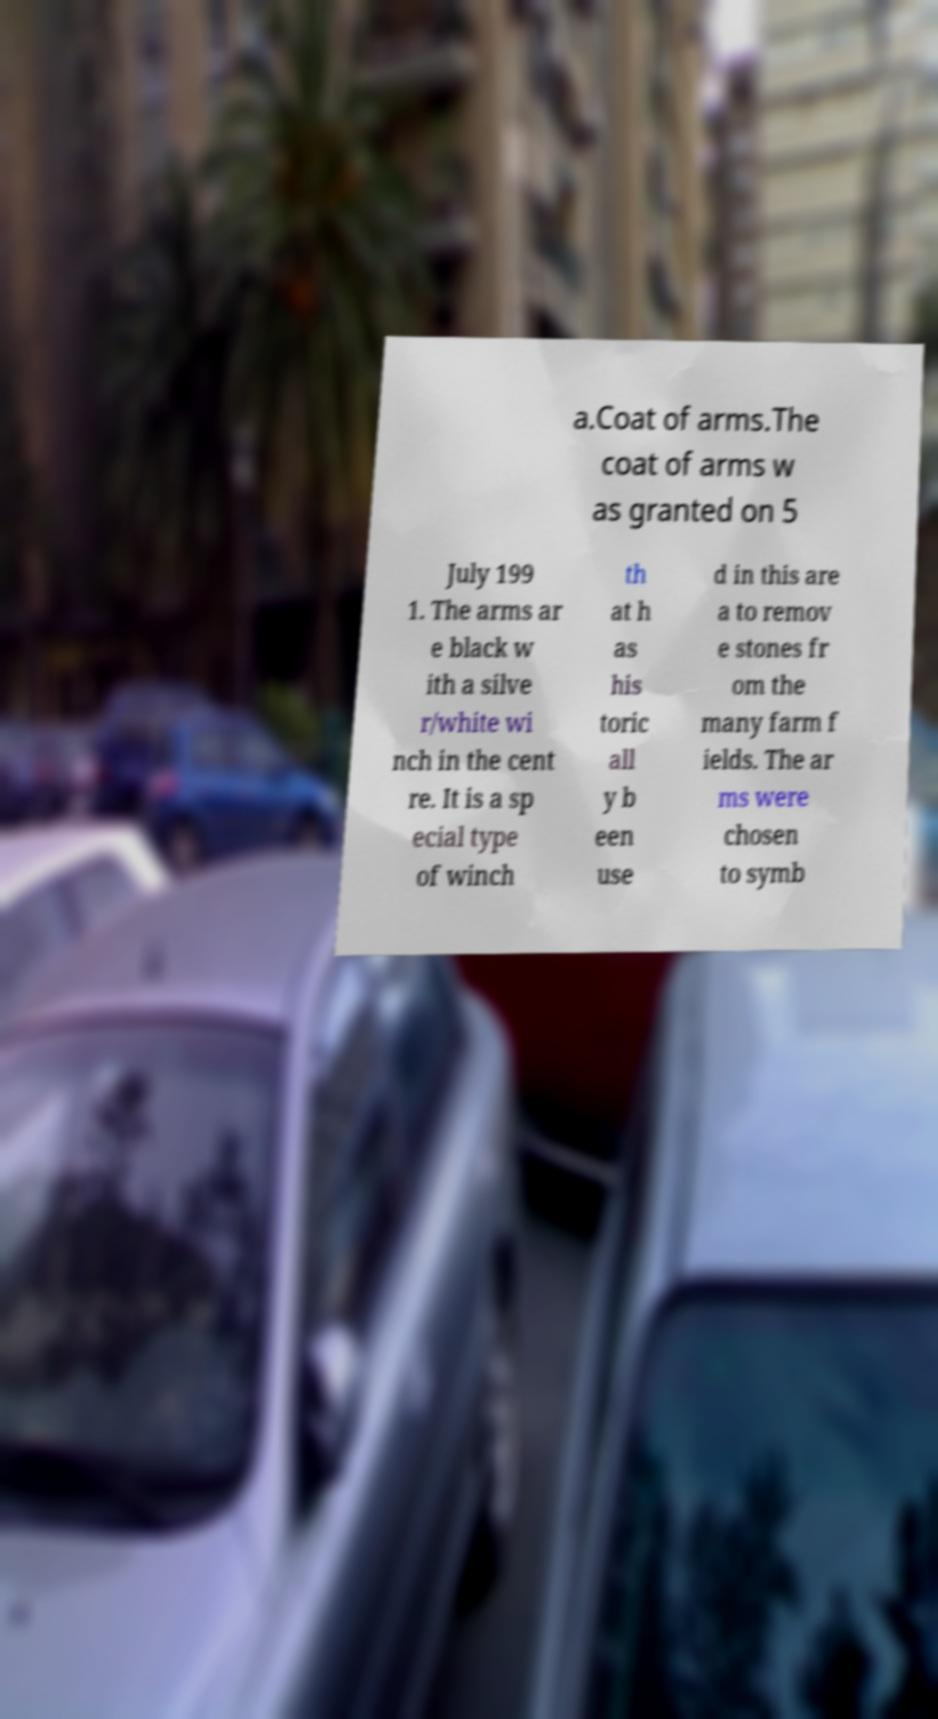There's text embedded in this image that I need extracted. Can you transcribe it verbatim? a.Coat of arms.The coat of arms w as granted on 5 July 199 1. The arms ar e black w ith a silve r/white wi nch in the cent re. It is a sp ecial type of winch th at h as his toric all y b een use d in this are a to remov e stones fr om the many farm f ields. The ar ms were chosen to symb 